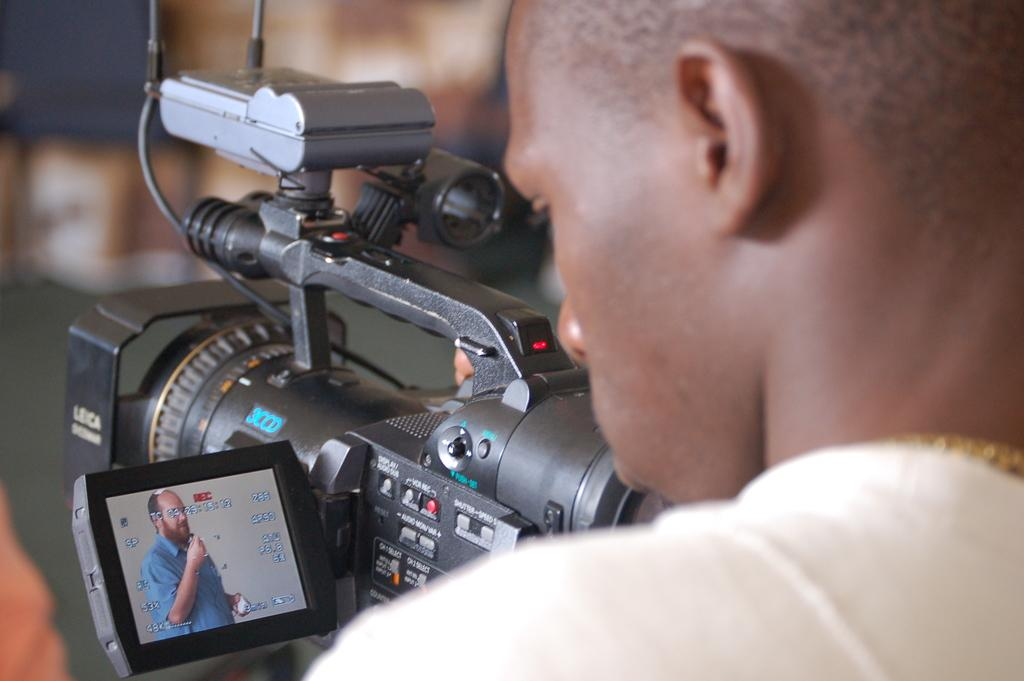Who is present in the image? There is a man in the image. What is the man doing in the image? The man is looking at the screen of a camera. What is happening to the camera in the image? The camera is being recorded. What type of army uniform is the monkey wearing in the image? There is no monkey present in the image, and therefore no army uniform can be observed. 